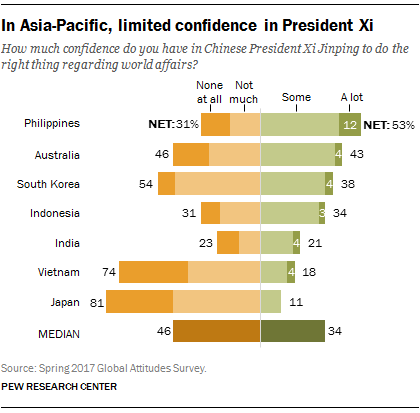Point out several critical features in this image. Australia has the second-highest value among countries. The value of the orange bar in India and Vietnam combined is 97. 